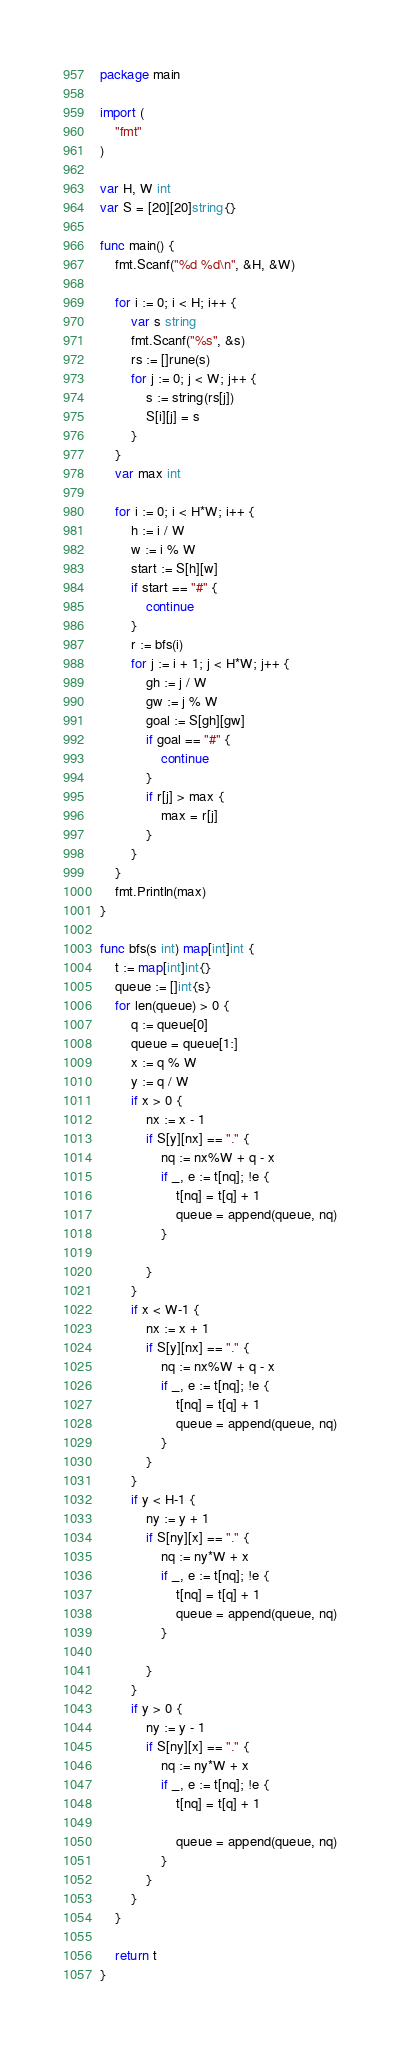<code> <loc_0><loc_0><loc_500><loc_500><_Go_>package main

import (
	"fmt"
)

var H, W int
var S = [20][20]string{}

func main() {
	fmt.Scanf("%d %d\n", &H, &W)

	for i := 0; i < H; i++ {
		var s string
		fmt.Scanf("%s", &s)
		rs := []rune(s)
		for j := 0; j < W; j++ {
			s := string(rs[j])
			S[i][j] = s
		}
	}
	var max int

	for i := 0; i < H*W; i++ {
		h := i / W
		w := i % W
		start := S[h][w]
		if start == "#" {
			continue
		}
		r := bfs(i)
		for j := i + 1; j < H*W; j++ {
			gh := j / W
			gw := j % W
			goal := S[gh][gw]
			if goal == "#" {
				continue
			}
			if r[j] > max {
				max = r[j]
			}
		}
	}
	fmt.Println(max)
}

func bfs(s int) map[int]int {
	t := map[int]int{}
	queue := []int{s}
	for len(queue) > 0 {
		q := queue[0]
		queue = queue[1:]
		x := q % W
		y := q / W
		if x > 0 {
			nx := x - 1
			if S[y][nx] == "." {
				nq := nx%W + q - x
				if _, e := t[nq]; !e {
					t[nq] = t[q] + 1
					queue = append(queue, nq)
				}

			}
		}
		if x < W-1 {
			nx := x + 1
			if S[y][nx] == "." {
				nq := nx%W + q - x
				if _, e := t[nq]; !e {
					t[nq] = t[q] + 1
					queue = append(queue, nq)
				}
			}
		}
		if y < H-1 {
			ny := y + 1
			if S[ny][x] == "." {
				nq := ny*W + x
				if _, e := t[nq]; !e {
					t[nq] = t[q] + 1
					queue = append(queue, nq)
				}

			}
		}
		if y > 0 {
			ny := y - 1
			if S[ny][x] == "." {
				nq := ny*W + x
				if _, e := t[nq]; !e {
					t[nq] = t[q] + 1

					queue = append(queue, nq)
				}
			}
		}
	}

	return t
}
</code> 